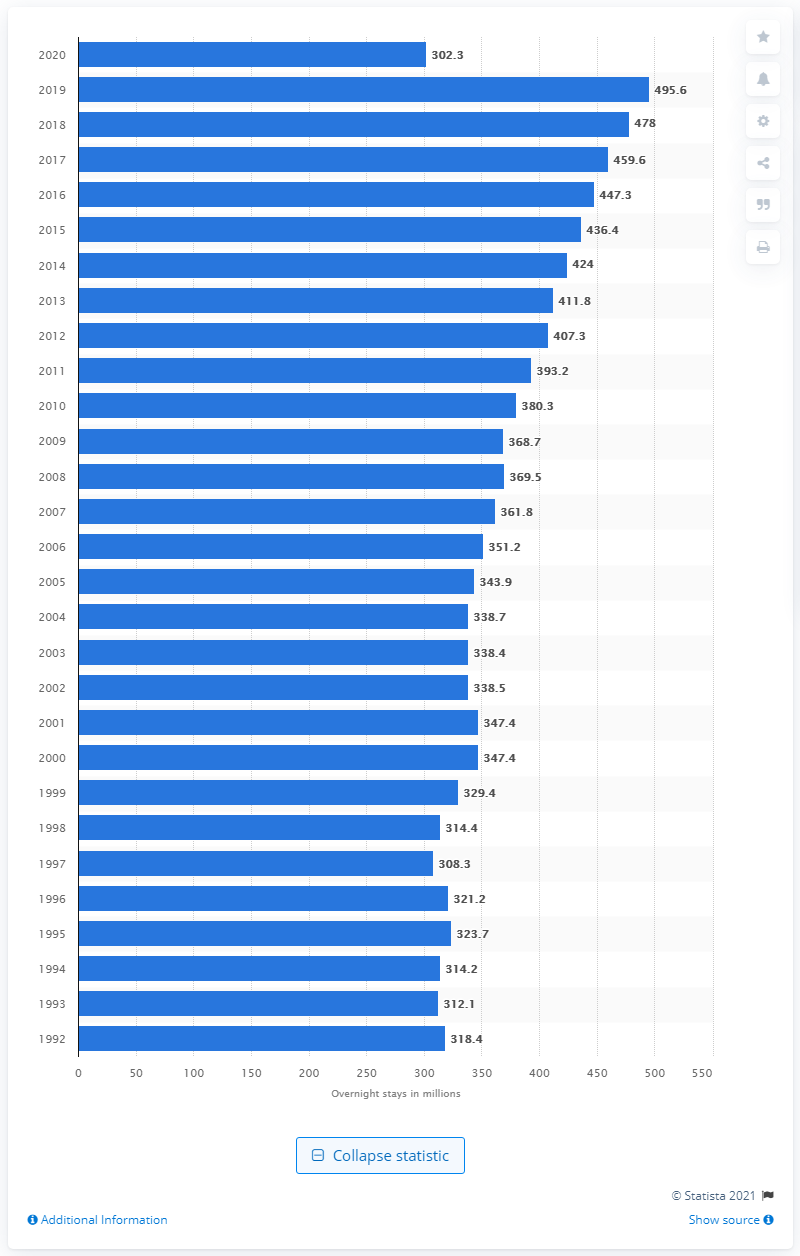Draw attention to some important aspects in this diagram. In 2020, it was predicted that there would be 302.3 overnight stays at travel accommodations in Germany. 